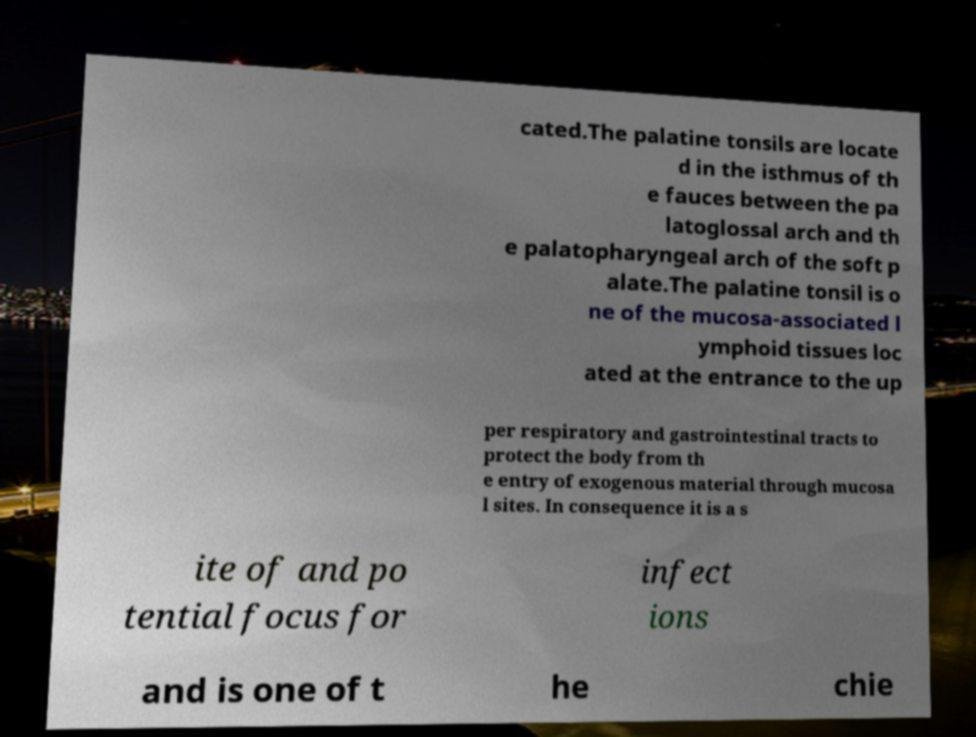For documentation purposes, I need the text within this image transcribed. Could you provide that? cated.The palatine tonsils are locate d in the isthmus of th e fauces between the pa latoglossal arch and th e palatopharyngeal arch of the soft p alate.The palatine tonsil is o ne of the mucosa-associated l ymphoid tissues loc ated at the entrance to the up per respiratory and gastrointestinal tracts to protect the body from th e entry of exogenous material through mucosa l sites. In consequence it is a s ite of and po tential focus for infect ions and is one of t he chie 